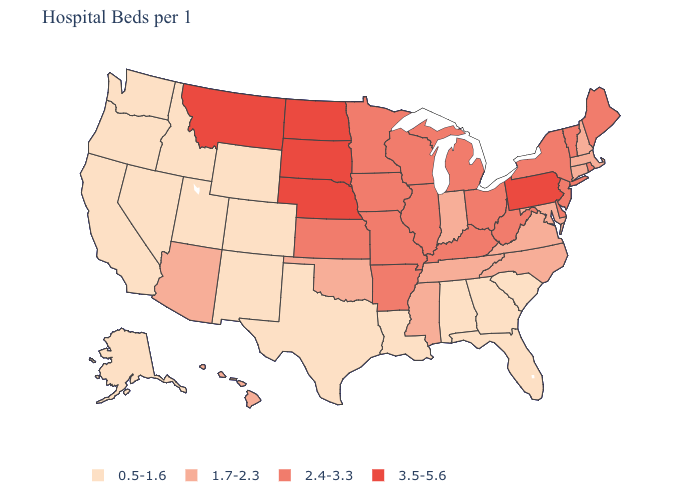What is the lowest value in states that border California?
Quick response, please. 0.5-1.6. Name the states that have a value in the range 1.7-2.3?
Answer briefly. Arizona, Connecticut, Hawaii, Indiana, Maryland, Massachusetts, Mississippi, New Hampshire, North Carolina, Oklahoma, Tennessee, Virginia. Name the states that have a value in the range 0.5-1.6?
Be succinct. Alabama, Alaska, California, Colorado, Florida, Georgia, Idaho, Louisiana, Nevada, New Mexico, Oregon, South Carolina, Texas, Utah, Washington, Wyoming. Name the states that have a value in the range 2.4-3.3?
Write a very short answer. Arkansas, Delaware, Illinois, Iowa, Kansas, Kentucky, Maine, Michigan, Minnesota, Missouri, New Jersey, New York, Ohio, Rhode Island, Vermont, West Virginia, Wisconsin. Name the states that have a value in the range 2.4-3.3?
Concise answer only. Arkansas, Delaware, Illinois, Iowa, Kansas, Kentucky, Maine, Michigan, Minnesota, Missouri, New Jersey, New York, Ohio, Rhode Island, Vermont, West Virginia, Wisconsin. Does Louisiana have a higher value than New Hampshire?
Quick response, please. No. Is the legend a continuous bar?
Keep it brief. No. Does New York have the lowest value in the Northeast?
Short answer required. No. Among the states that border Alabama , does Tennessee have the highest value?
Give a very brief answer. Yes. Name the states that have a value in the range 2.4-3.3?
Keep it brief. Arkansas, Delaware, Illinois, Iowa, Kansas, Kentucky, Maine, Michigan, Minnesota, Missouri, New Jersey, New York, Ohio, Rhode Island, Vermont, West Virginia, Wisconsin. What is the value of New York?
Short answer required. 2.4-3.3. Name the states that have a value in the range 1.7-2.3?
Keep it brief. Arizona, Connecticut, Hawaii, Indiana, Maryland, Massachusetts, Mississippi, New Hampshire, North Carolina, Oklahoma, Tennessee, Virginia. What is the value of Arizona?
Quick response, please. 1.7-2.3. Which states have the lowest value in the USA?
Write a very short answer. Alabama, Alaska, California, Colorado, Florida, Georgia, Idaho, Louisiana, Nevada, New Mexico, Oregon, South Carolina, Texas, Utah, Washington, Wyoming. What is the value of Oregon?
Answer briefly. 0.5-1.6. 